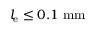<formula> <loc_0><loc_0><loc_500><loc_500>l _ { e } \leq 0 . 1 \ m m</formula> 